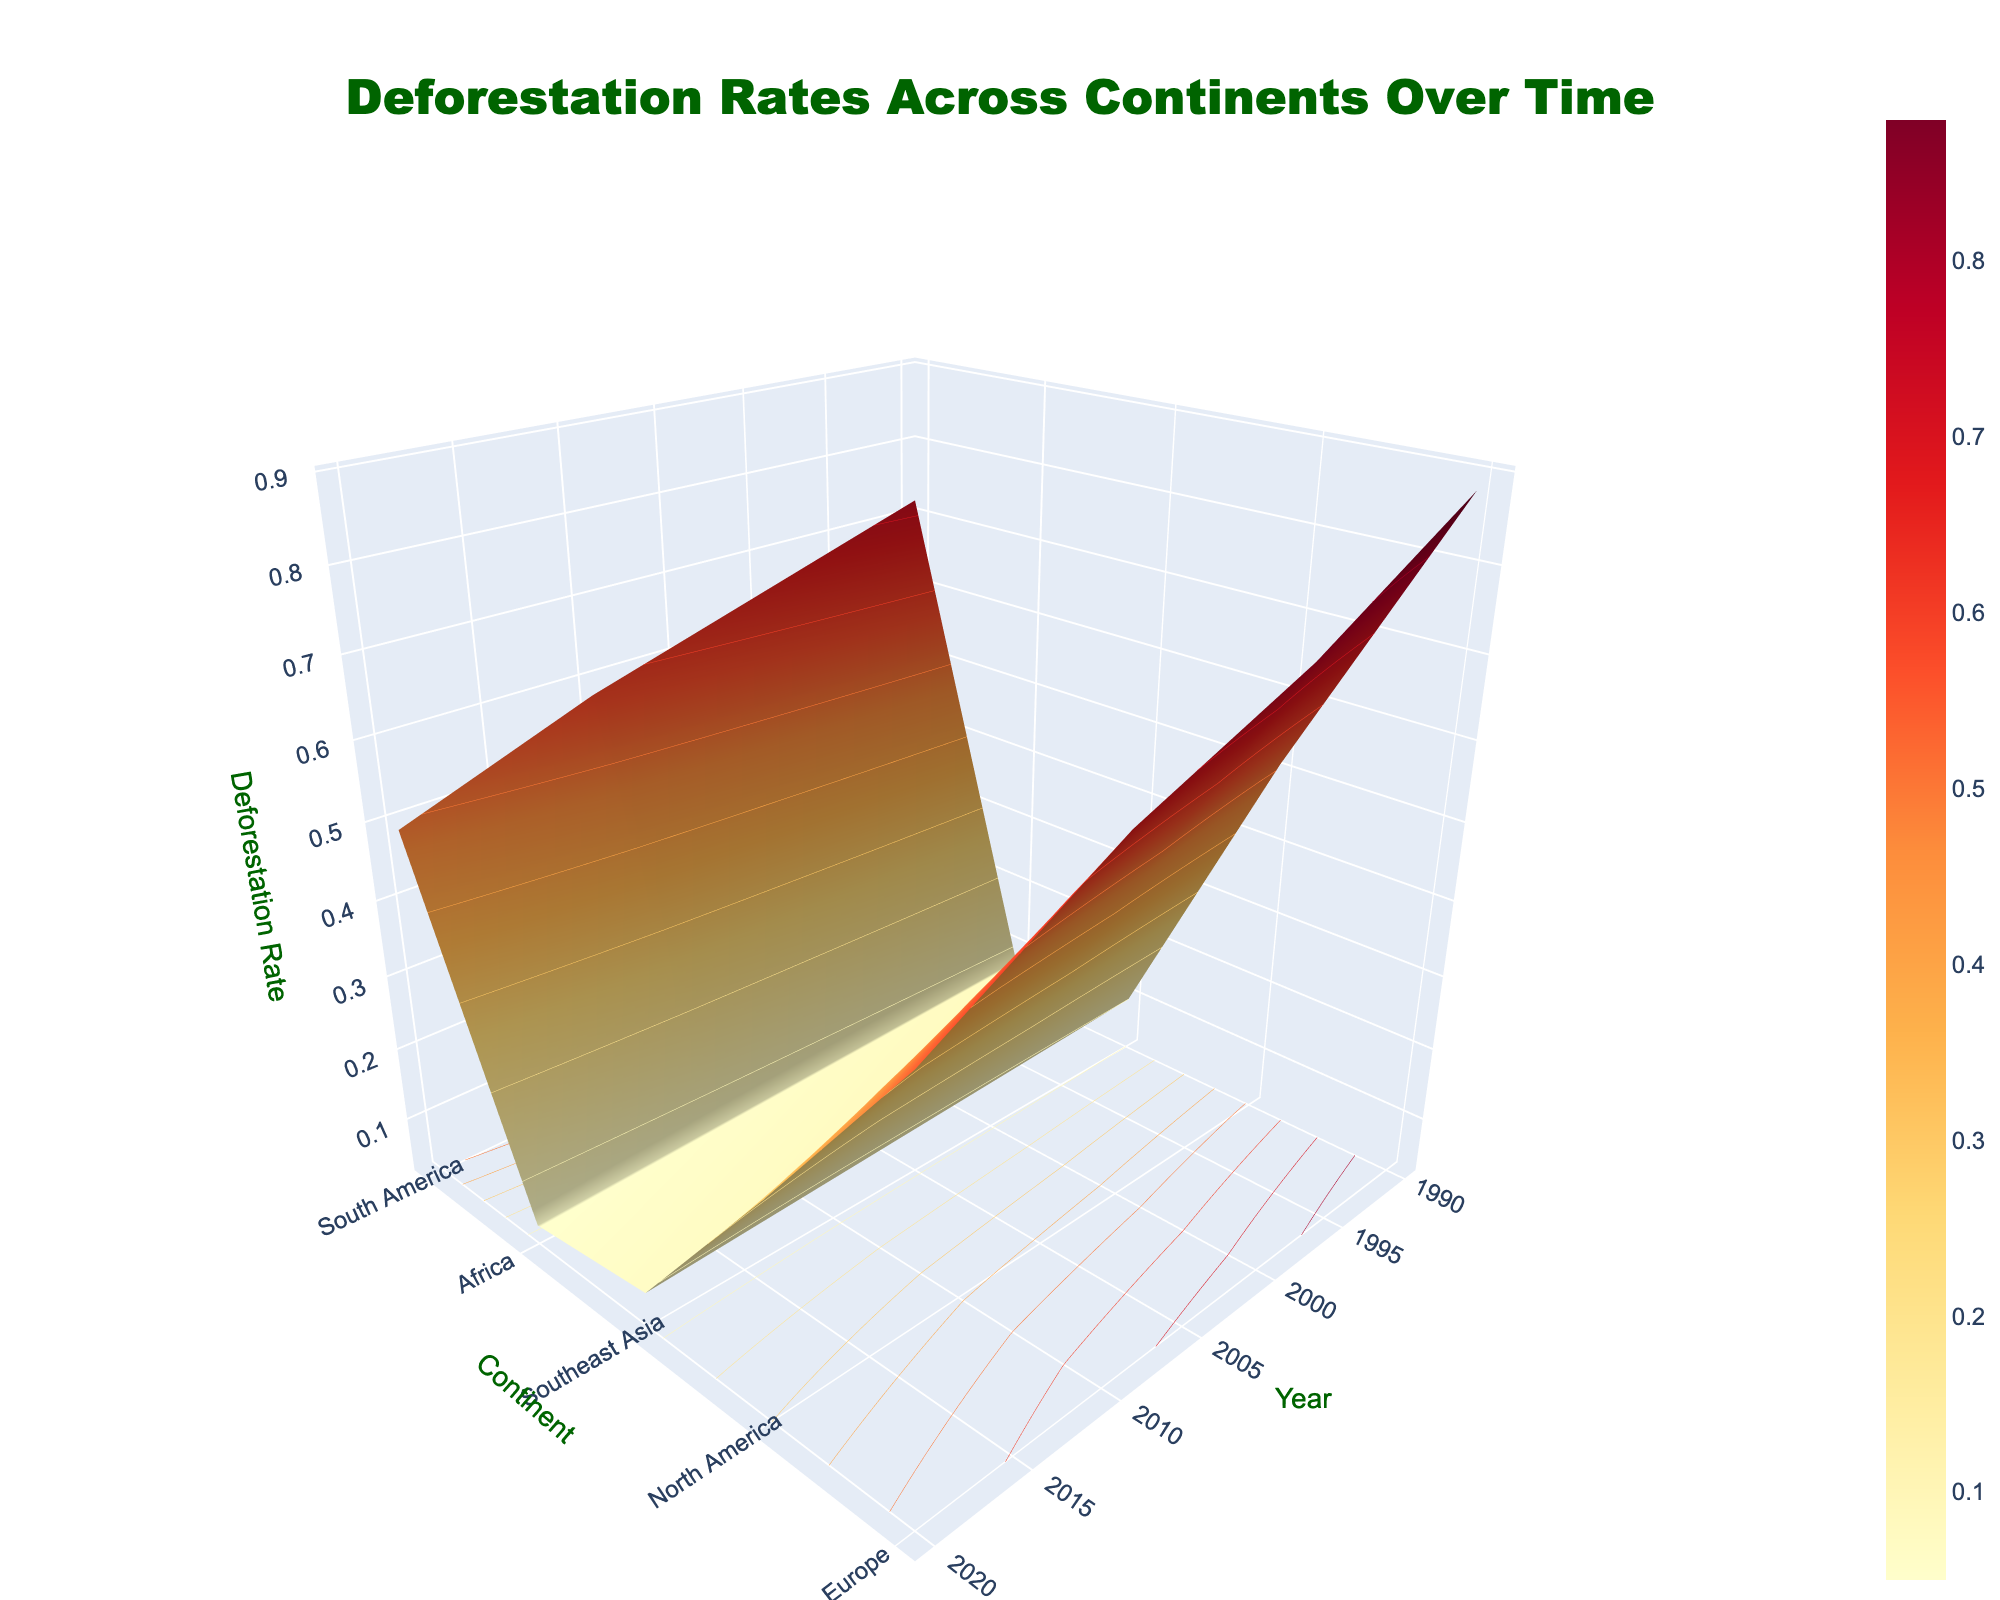Who has the highest deforestation rate in 1990? By examining the figure from the year 1990, we can see which y-axis value has the highest z-axis (Deforestation Rate) value among the continents. Southeast Asia is at the top with a value of 0.88.
Answer: Southeast Asia How did the deforestation rate of Africa change from 1990 to 2020? We look at the Africa line on the y-axis and observe the change in z-values from 1990 to 2020. In 1990, it started at 0.72 and decreased to 0.49 in 2020.
Answer: Decreased from 0.72 to 0.49 Which continent showed the most significant reduction in deforestation rate over the period? By comparing the overall heights on the z-axis for all continents from 1990 to 2020, Southeast Asia shows the largest drop from 0.88 to 0.54.
Answer: Southeast Asia Compare the deforestation rates of South America and North America in 2020. Which one is higher? For the year 2020, we check the z-values for South America and North America. South America has a rate of 0.30, while North America’s rate is 0.07. Therefore, South America's rate is higher.
Answer: South America What is the average deforestation rate in Europe across all displayed years? Adding up the deforestation rates in Europe for 1990 (0.08), 2000 (0.07), 2010 (0.06), and 2020 (0.05) amounts to 0.26. Dividing this by 4 years results in an average rate.
Answer: 0.065 What trend do you observe for deforestation rates in North America across the years depicted? By looking at the North American line on the y-axis, the z-values consistently decrease from 0.10 in 1990 to 0.07 in 2020, showing a slow downward trend.
Answer: Decreasing trend Between 2000 and 2010, which continent experienced a greater decrease in deforestation rates: Africa or Southeast Asia? For Africa, the rate dropped from 0.65 to 0.58 (0.07 decrease). For Southeast Asia, it dropped from 0.76 to 0.67 (0.09 decrease). Southeast Asia experienced a greater decrease.
Answer: Southeast Asia In which year did South America have the closest deforestation rate to 0.40? Looking at the z-values for South America across different years, 2010 has a value of 0.39, which is closest to 0.40.
Answer: 2010 